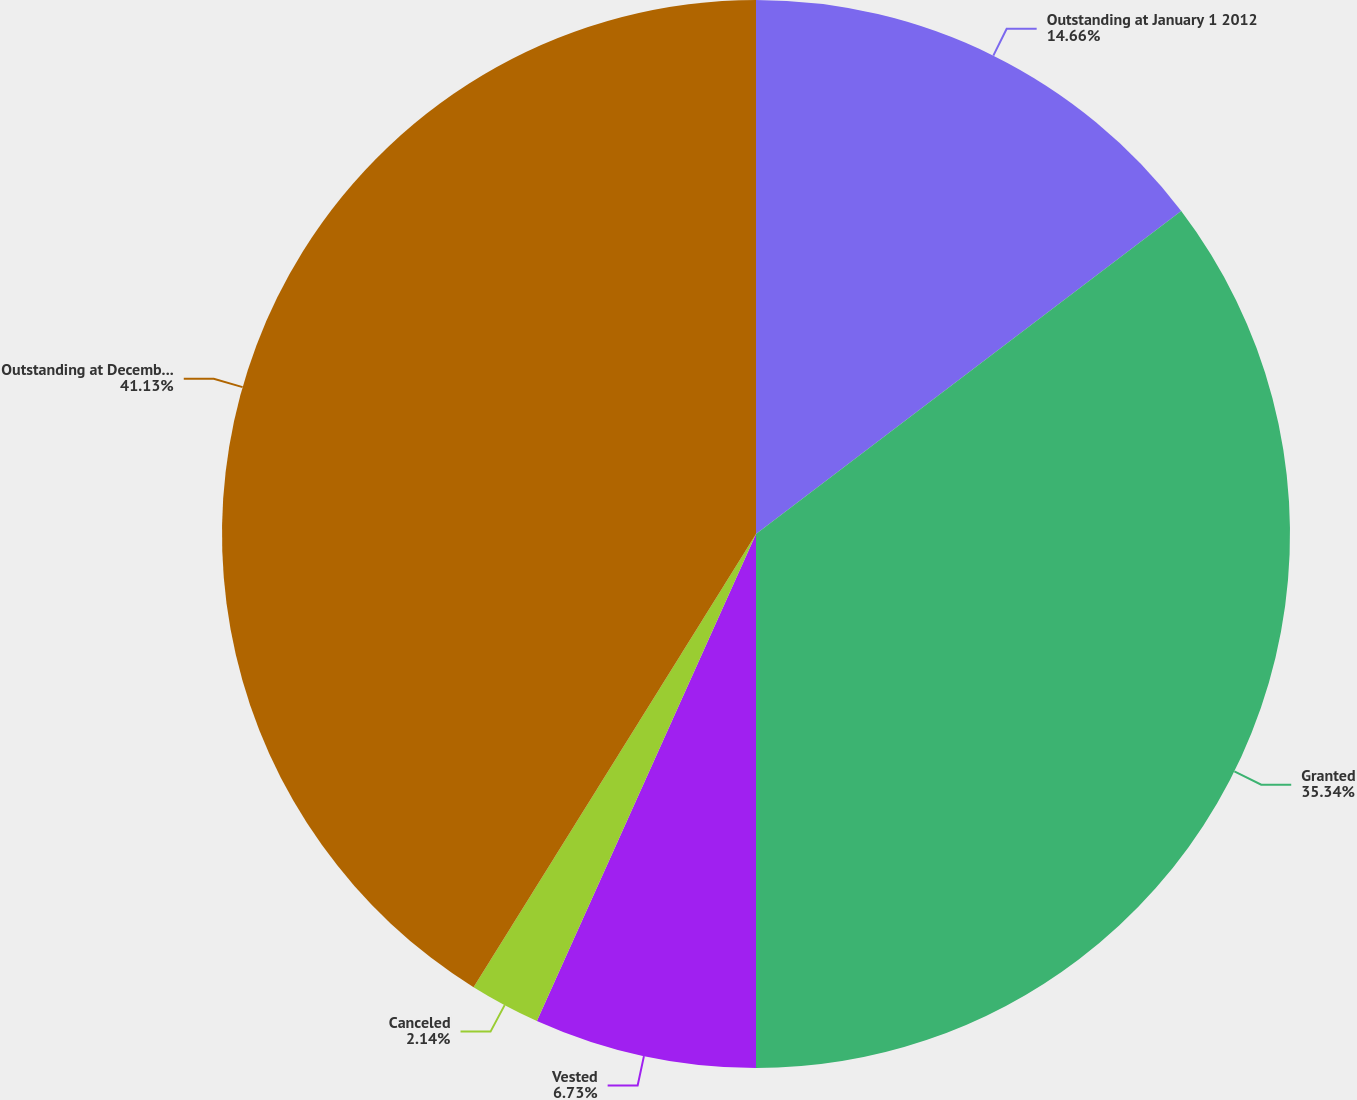Convert chart. <chart><loc_0><loc_0><loc_500><loc_500><pie_chart><fcel>Outstanding at January 1 2012<fcel>Granted<fcel>Vested<fcel>Canceled<fcel>Outstanding at December 31<nl><fcel>14.66%<fcel>35.34%<fcel>6.73%<fcel>2.14%<fcel>41.13%<nl></chart> 